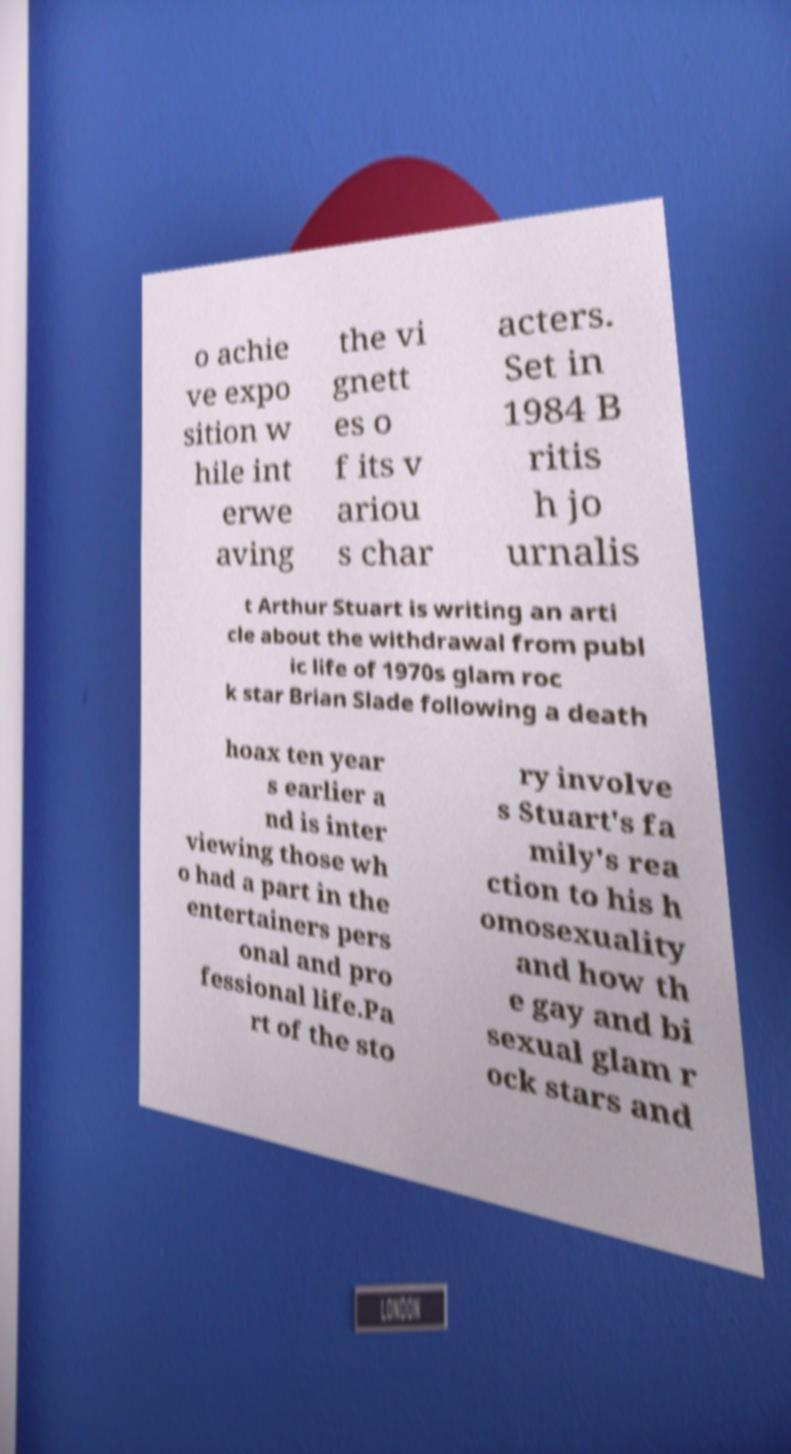Please read and relay the text visible in this image. What does it say? o achie ve expo sition w hile int erwe aving the vi gnett es o f its v ariou s char acters. Set in 1984 B ritis h jo urnalis t Arthur Stuart is writing an arti cle about the withdrawal from publ ic life of 1970s glam roc k star Brian Slade following a death hoax ten year s earlier a nd is inter viewing those wh o had a part in the entertainers pers onal and pro fessional life.Pa rt of the sto ry involve s Stuart's fa mily's rea ction to his h omosexuality and how th e gay and bi sexual glam r ock stars and 